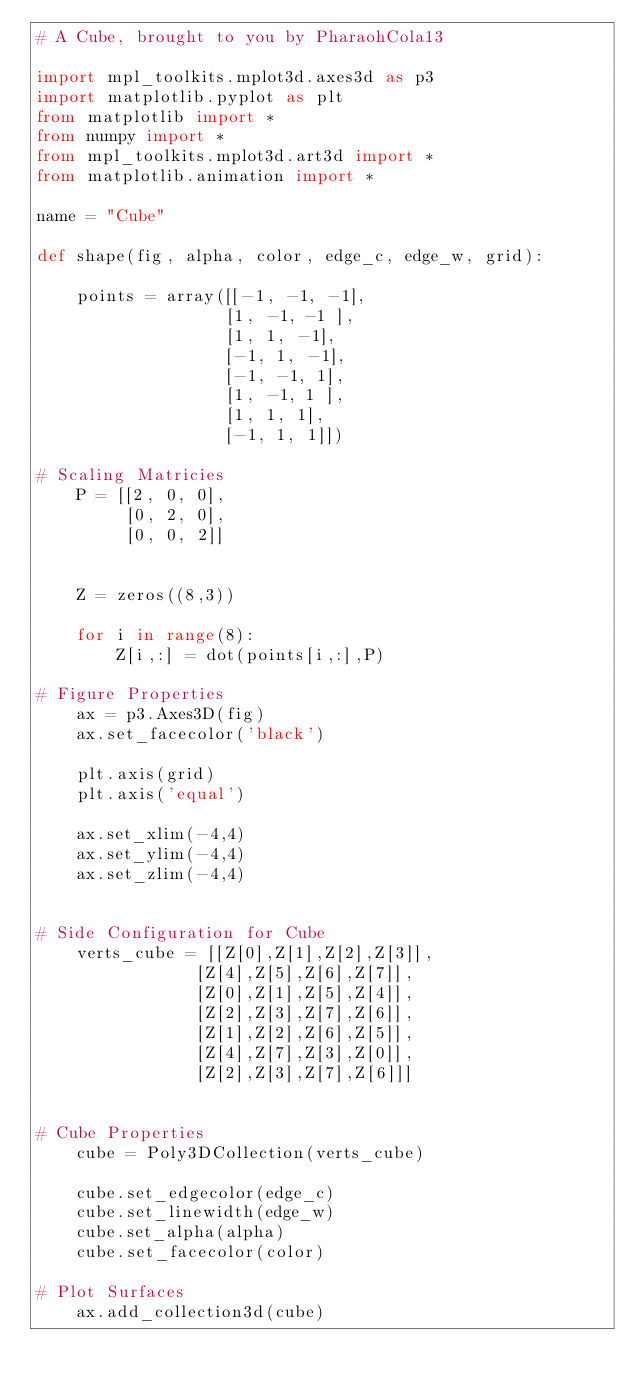Convert code to text. <code><loc_0><loc_0><loc_500><loc_500><_Python_># A Cube, brought to you by PharaohCola13

import mpl_toolkits.mplot3d.axes3d as p3
import matplotlib.pyplot as plt
from matplotlib import *
from numpy import *
from mpl_toolkits.mplot3d.art3d import *
from matplotlib.animation import *

name = "Cube"

def shape(fig, alpha, color, edge_c, edge_w, grid):

	points = array([[-1, -1, -1],
	               [1, -1, -1 ],
	               [1, 1, -1],
	               [-1, 1, -1],
	               [-1, -1, 1],
	               [1, -1, 1 ],
	               [1, 1, 1],
	               [-1, 1, 1]])

# Scaling Matricies
	P = [[2, 0, 0],
		 [0, 2, 0],
		 [0, 0, 2]]


	Z = zeros((8,3))

	for i in range(8): 
		Z[i,:] = dot(points[i,:],P)

# Figure Properties
	ax = p3.Axes3D(fig)
	ax.set_facecolor('black')
	
	plt.axis(grid)
	plt.axis('equal')
	
	ax.set_xlim(-4,4)
	ax.set_ylim(-4,4)
	ax.set_zlim(-4,4)


# Side Configuration for Cube
	verts_cube = [[Z[0],Z[1],Z[2],Z[3]],
				[Z[4],Z[5],Z[6],Z[7]], 
				[Z[0],Z[1],Z[5],Z[4]], 
				[Z[2],Z[3],Z[7],Z[6]], 
				[Z[1],Z[2],Z[6],Z[5]],
				[Z[4],Z[7],Z[3],Z[0]], 
				[Z[2],Z[3],Z[7],Z[6]]]


# Cube Properties
	cube = Poly3DCollection(verts_cube)

	cube.set_edgecolor(edge_c)
	cube.set_linewidth(edge_w)
	cube.set_alpha(alpha)
	cube.set_facecolor(color)

# Plot Surfaces
	ax.add_collection3d(cube)
</code> 